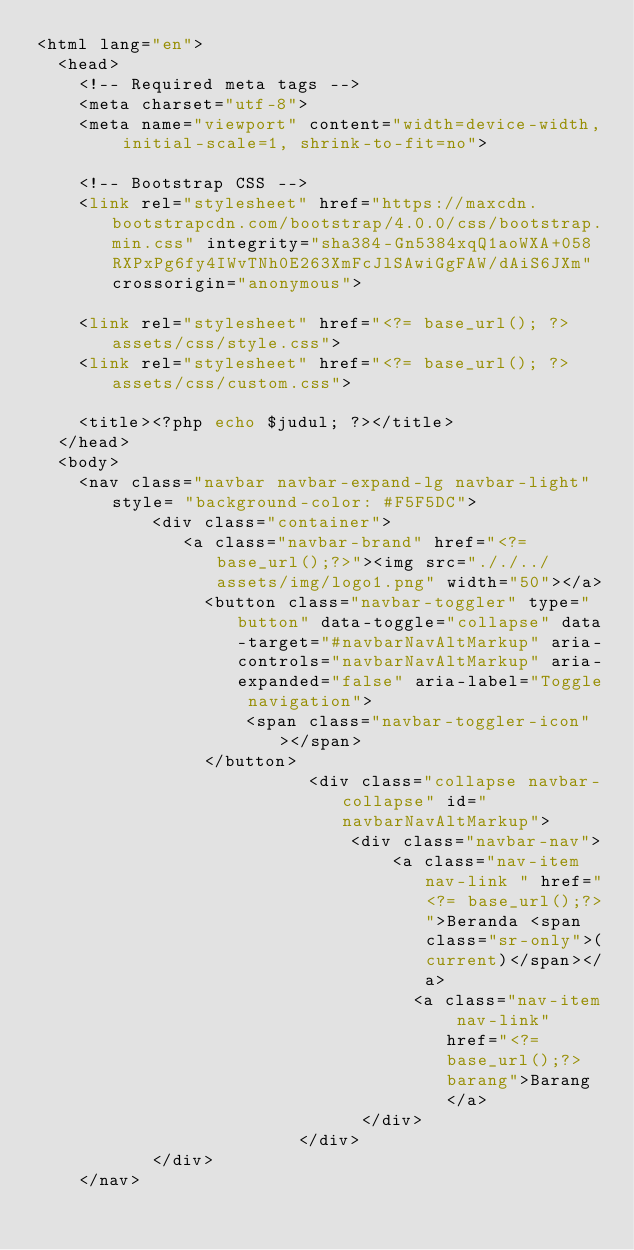Convert code to text. <code><loc_0><loc_0><loc_500><loc_500><_PHP_><html lang="en">
  <head>
    <!-- Required meta tags -->
    <meta charset="utf-8">
    <meta name="viewport" content="width=device-width, initial-scale=1, shrink-to-fit=no">

    <!-- Bootstrap CSS -->
    <link rel="stylesheet" href="https://maxcdn.bootstrapcdn.com/bootstrap/4.0.0/css/bootstrap.min.css" integrity="sha384-Gn5384xqQ1aoWXA+058RXPxPg6fy4IWvTNh0E263XmFcJlSAwiGgFAW/dAiS6JXm" crossorigin="anonymous">
    
    <link rel="stylesheet" href="<?= base_url(); ?>assets/css/style.css">
    <link rel="stylesheet" href="<?= base_url(); ?>assets/css/custom.css">

    <title><?php echo $judul; ?></title>
  </head>
  <body>
    <nav class="navbar navbar-expand-lg navbar-light" style= "background-color: #F5F5DC">
           <div class="container">
              <a class="navbar-brand" href="<?= base_url();?>"><img src="././../assets/img/logo1.png" width="50"></a>
                <button class="navbar-toggler" type="button" data-toggle="collapse" data-target="#navbarNavAltMarkup" aria-controls="navbarNavAltMarkup" aria-expanded="false" aria-label="Toggle navigation">
                    <span class="navbar-toggler-icon"></span>
                </button>
                          <div class="collapse navbar-collapse" id="navbarNavAltMarkup">
                              <div class="navbar-nav">
                                  <a class="nav-item nav-link " href="<?= base_url();?>">Beranda <span class="sr-only">(current)</span></a>
                                    <a class="nav-item nav-link"  href="<?= base_url();?>barang">Barang</a>
                               </div>
                         </div>
           </div>
    </nav>

</code> 